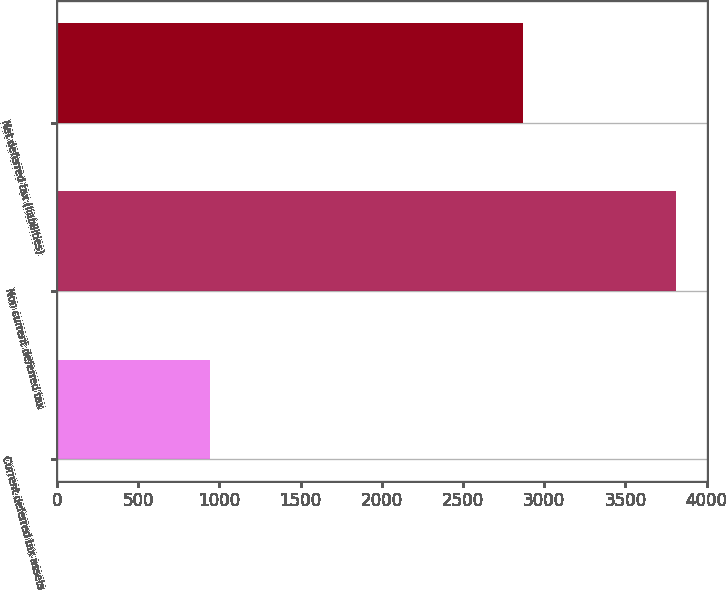Convert chart. <chart><loc_0><loc_0><loc_500><loc_500><bar_chart><fcel>Current deferred tax assets<fcel>Non current deferred tax<fcel>Net deferred tax (liabilities)<nl><fcel>944<fcel>3811<fcel>2867<nl></chart> 